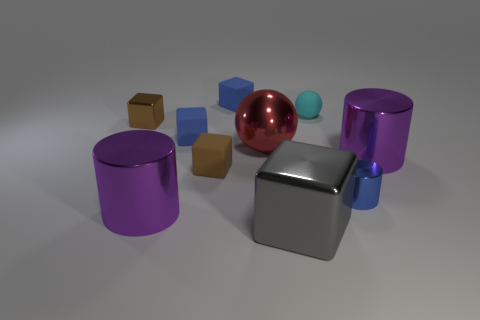There is another tiny block that is the same color as the small metallic cube; what material is it?
Provide a short and direct response. Rubber. What is the shape of the big purple object behind the brown rubber object behind the big cube that is left of the tiny cyan rubber thing?
Ensure brevity in your answer.  Cylinder. What number of blue cylinders are made of the same material as the small cyan sphere?
Keep it short and to the point. 0. How many metallic things are left of the sphere behind the large red thing?
Your answer should be compact. 4. What number of small brown rubber cubes are there?
Provide a short and direct response. 1. Is the gray block made of the same material as the big purple object that is right of the tiny blue metallic thing?
Keep it short and to the point. Yes. Is the color of the large cylinder to the right of the big gray metal block the same as the big metal block?
Offer a very short reply. No. There is a blue thing that is both in front of the brown shiny object and behind the blue shiny cylinder; what material is it made of?
Keep it short and to the point. Rubber. What is the size of the blue cylinder?
Your answer should be very brief. Small. There is a shiny sphere; is its color the same as the metal cylinder left of the big sphere?
Your answer should be very brief. No. 